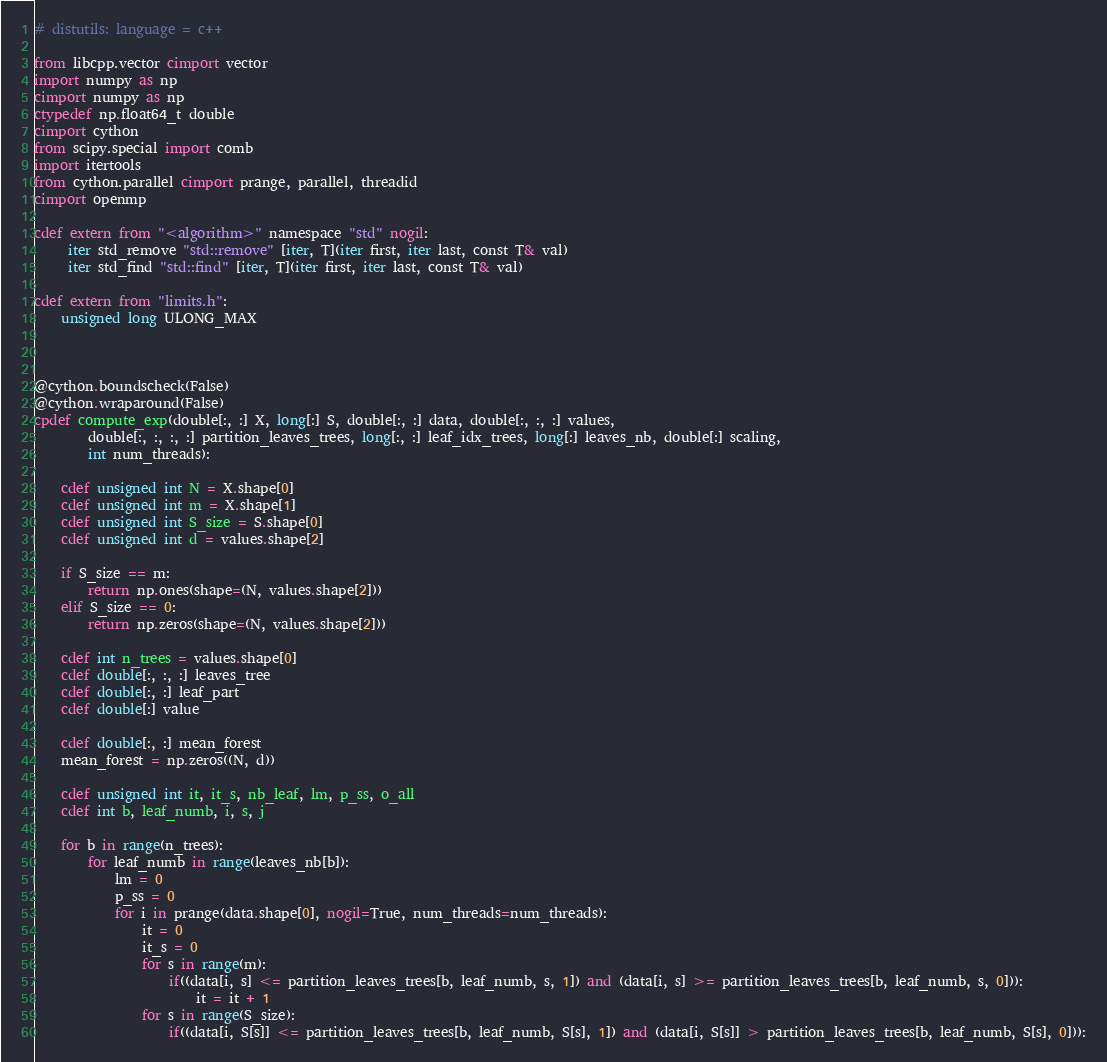<code> <loc_0><loc_0><loc_500><loc_500><_Cython_># distutils: language = c++

from libcpp.vector cimport vector
import numpy as np
cimport numpy as np
ctypedef np.float64_t double
cimport cython
from scipy.special import comb
import itertools
from cython.parallel cimport prange, parallel, threadid
cimport openmp

cdef extern from "<algorithm>" namespace "std" nogil:
     iter std_remove "std::remove" [iter, T](iter first, iter last, const T& val)
     iter std_find "std::find" [iter, T](iter first, iter last, const T& val)

cdef extern from "limits.h":
    unsigned long ULONG_MAX



@cython.boundscheck(False)
@cython.wraparound(False)
cpdef compute_exp(double[:, :] X, long[:] S, double[:, :] data, double[:, :, :] values,
        double[:, :, :, :] partition_leaves_trees, long[:, :] leaf_idx_trees, long[:] leaves_nb, double[:] scaling,
        int num_threads):

    cdef unsigned int N = X.shape[0]
    cdef unsigned int m = X.shape[1]
    cdef unsigned int S_size = S.shape[0]
    cdef unsigned int d = values.shape[2]

    if S_size == m:
        return np.ones(shape=(N, values.shape[2]))
    elif S_size == 0:
        return np.zeros(shape=(N, values.shape[2]))

    cdef int n_trees = values.shape[0]
    cdef double[:, :, :] leaves_tree
    cdef double[:, :] leaf_part
    cdef double[:] value

    cdef double[:, :] mean_forest
    mean_forest = np.zeros((N, d))

    cdef unsigned int it, it_s, nb_leaf, lm, p_ss, o_all
    cdef int b, leaf_numb, i, s, j

    for b in range(n_trees):
        for leaf_numb in range(leaves_nb[b]):
            lm = 0
            p_ss = 0
            for i in prange(data.shape[0], nogil=True, num_threads=num_threads):
                it = 0
                it_s = 0
                for s in range(m):
                    if((data[i, s] <= partition_leaves_trees[b, leaf_numb, s, 1]) and (data[i, s] >= partition_leaves_trees[b, leaf_numb, s, 0])):
                        it = it + 1
                for s in range(S_size):
                    if((data[i, S[s]] <= partition_leaves_trees[b, leaf_numb, S[s], 1]) and (data[i, S[s]] > partition_leaves_trees[b, leaf_numb, S[s], 0])):</code> 